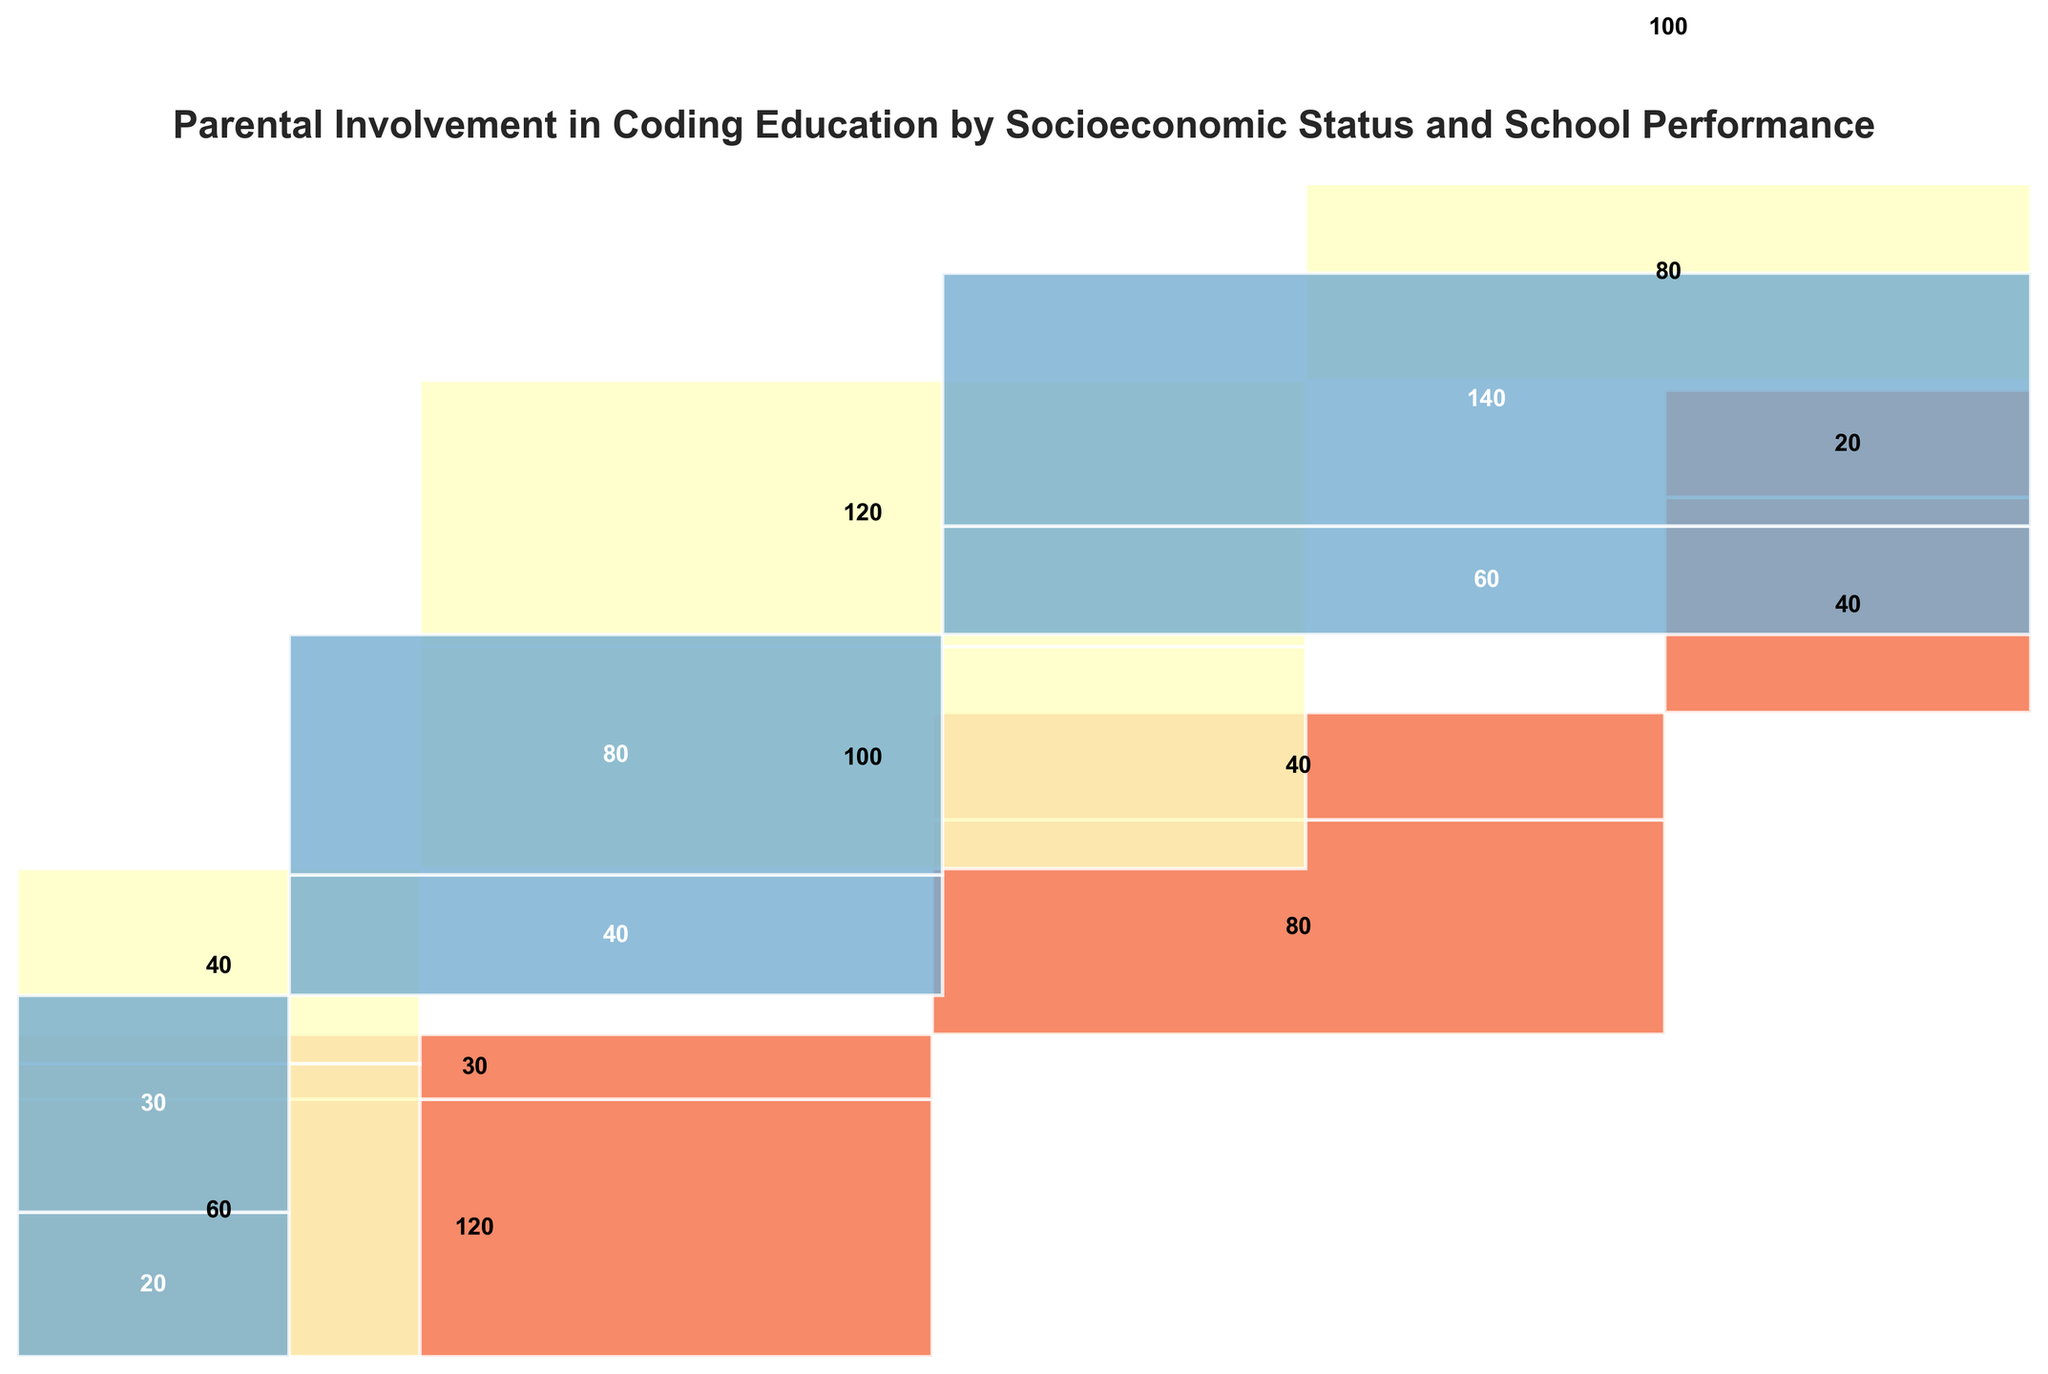Which socioeconomic status has the highest total parent involvement? The 'High' socioeconomic status has the most parental involvement, both 'Low' and 'High' marks combine for larger sections within the mosaic plot.
Answer: High How much higher is the involvement in coding education for middle socioeconomic status compared to low status for students with average school performance? Combine counts of high involvement for both statuses first. Middle status (120) - Low status (40) = 80.
Answer: 80 Which school performance category within the high socioeconomic group has the highest level of parental involvement? Within the 'High' socioeconomic group, 'Above Average' performance has the highest level of parental involvement of 140.
Answer: Above Average Compare the parental involvement patterns between middle and low socioeconomic statuses across all school performance categories. For 'Below Average', middle has more high involvement (40 vs. 30). For 'Average', middle again has more high involvement (120 vs. 40). For 'Above Average', middle maintains higher involvement (100 vs. 20). In every category, middle shows equal or higher parental involvement than low.
Answer: Middle has consistently higher involvement What is the total count of students with high parental involvement in coding education across all socioeconomic statuses? Sum high involvements: 30 (Low) + 40 (Middle) + 30 (High) = 100 for Below Average; 40 (Low) + 120 (Middle) + 80 (High) = 240 for Average; 20 (Low) + 100 (Middle) + 140 (High) = 260 for Above Average. Adding those: 100 + 240 + 260 = 600.
Answer: 600 Which socioeconomic status and school performance combination has the lowest parental involvement count? 'High' socioeconomic status with 'Below Average' school performance, with involvement count of 20.
Answer: High, Below Average How does parental involvement in coding education vary with school performance within the low socioeconomic status? In low status, below average: 120 (Low involvement) vs. 30 (High), average: 80 (Low) vs. 40 (High), above average: 40 (Low) vs. 20 (High). Highest involvement occurs in below-average performance.
Answer: Highest in below average Based on the mosaic plot, which group shows the most balanced distribution of parental involvement across all school performance levels? Inputs: Low/high counts for each performance level. 'Middle' status is most balanced, having 40/120 high and 60/100 low involvement across 'Below Average' and 'Average' groupings.
Answer: Middle How many additional high parental involvement students would need to move from middle to low socioeconomic status in 'Average' school performance to equalize the counts of high parental involvement between both statuses? Count difference: 120 (Middle) - 40 (Low) = 80.
Answer: 80 